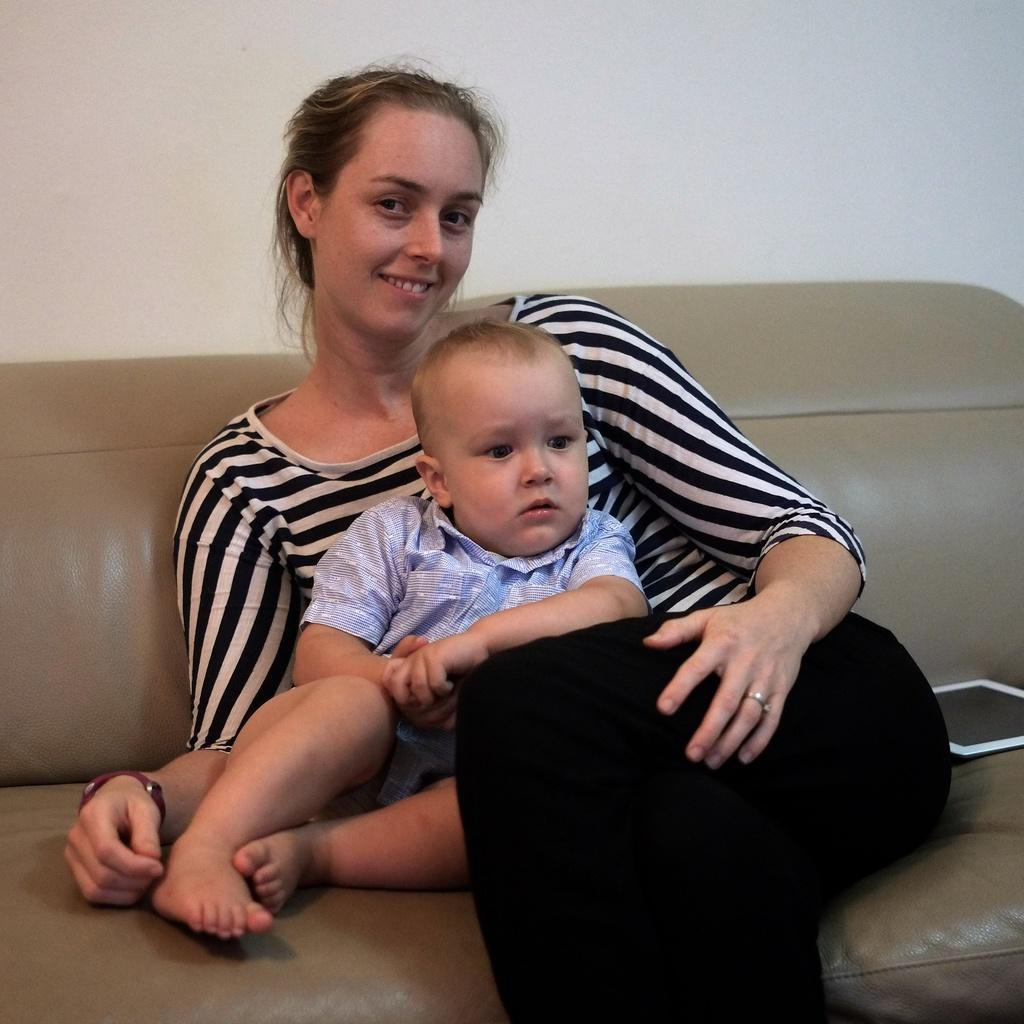Who are the people in the image? There is a boy and a woman in the image. What are they doing in the image? Both the boy and the woman are sitting on a couch. What device can be seen in the image? There is an iPad in the image, which is white in color. How is the woman feeling in the image? The woman is smiling. What is visible in the background of the image? There is a wall visible in the image. Can you see the sea in the image? No, the sea is not present in the image. What is the angle of the boy's stomach in the image? There is no information about the angle of the boy's stomach in the image, as it is not mentioned in the provided facts. 